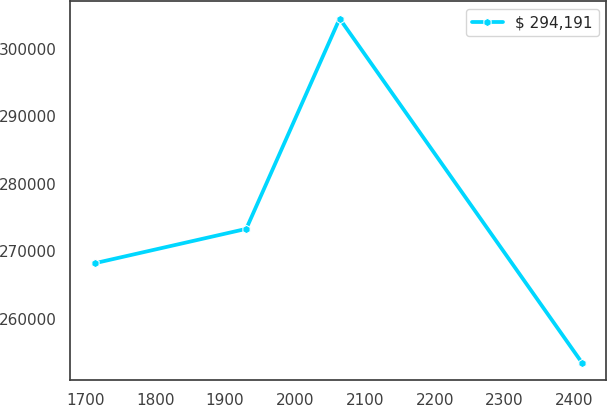Convert chart to OTSL. <chart><loc_0><loc_0><loc_500><loc_500><line_chart><ecel><fcel>$ 294,191<nl><fcel>1713.32<fcel>268214<nl><fcel>1930.28<fcel>273315<nl><fcel>2063.89<fcel>304506<nl><fcel>2410.39<fcel>253490<nl></chart> 